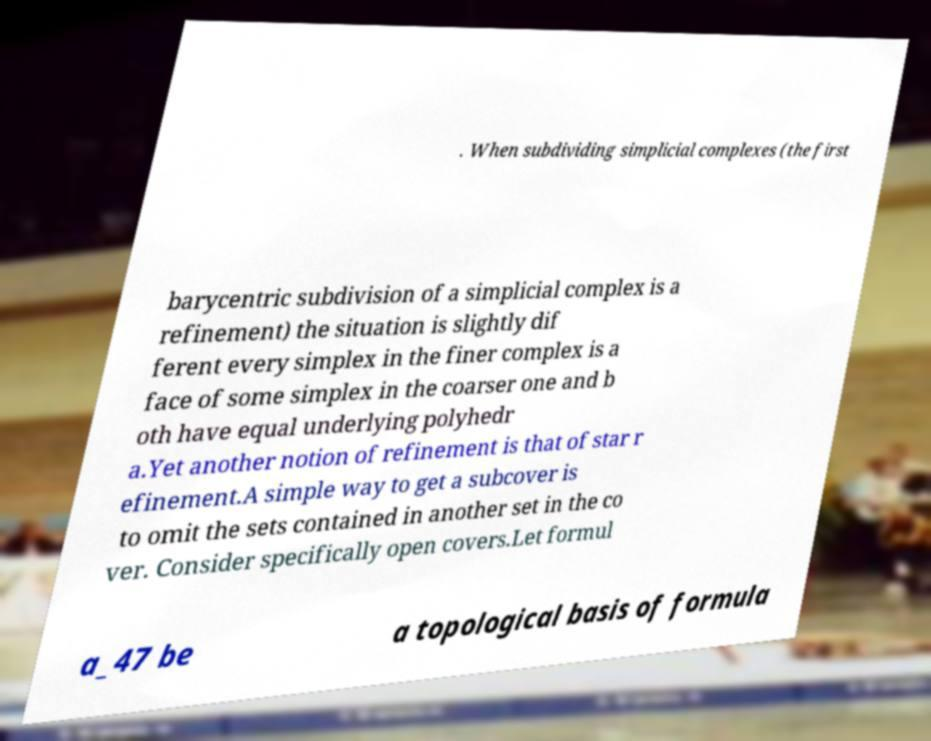For documentation purposes, I need the text within this image transcribed. Could you provide that? . When subdividing simplicial complexes (the first barycentric subdivision of a simplicial complex is a refinement) the situation is slightly dif ferent every simplex in the finer complex is a face of some simplex in the coarser one and b oth have equal underlying polyhedr a.Yet another notion of refinement is that of star r efinement.A simple way to get a subcover is to omit the sets contained in another set in the co ver. Consider specifically open covers.Let formul a_47 be a topological basis of formula 